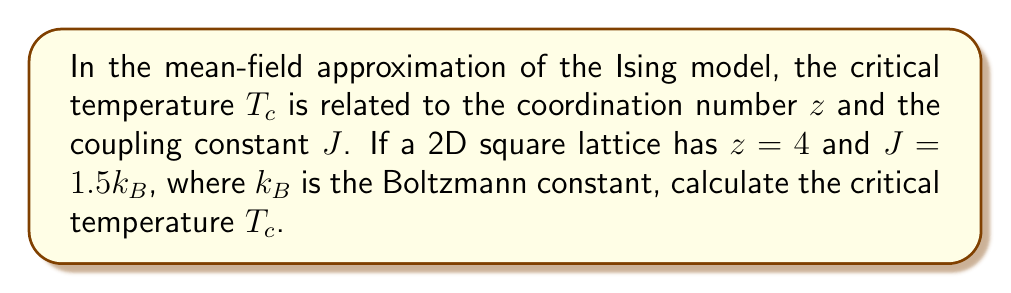What is the answer to this math problem? Let's approach this step-by-step:

1) In the mean-field approximation, the critical temperature $T_c$ is given by:

   $$T_c = \frac{zJ}{k_B}$$

   where $z$ is the coordination number, $J$ is the coupling constant, and $k_B$ is the Boltzmann constant.

2) We are given:
   - $z = 4$ (for a 2D square lattice)
   - $J = 1.5k_B$

3) Substituting these values into the equation:

   $$T_c = \frac{4 \cdot 1.5k_B}{k_B}$$

4) Simplify:

   $$T_c = 6$$

5) Since $J$ was given in units of $k_B$, our result is in units of $k_B$ as well.

Therefore, the critical temperature is $6k_B$.
Answer: $T_c = 6k_B$ 